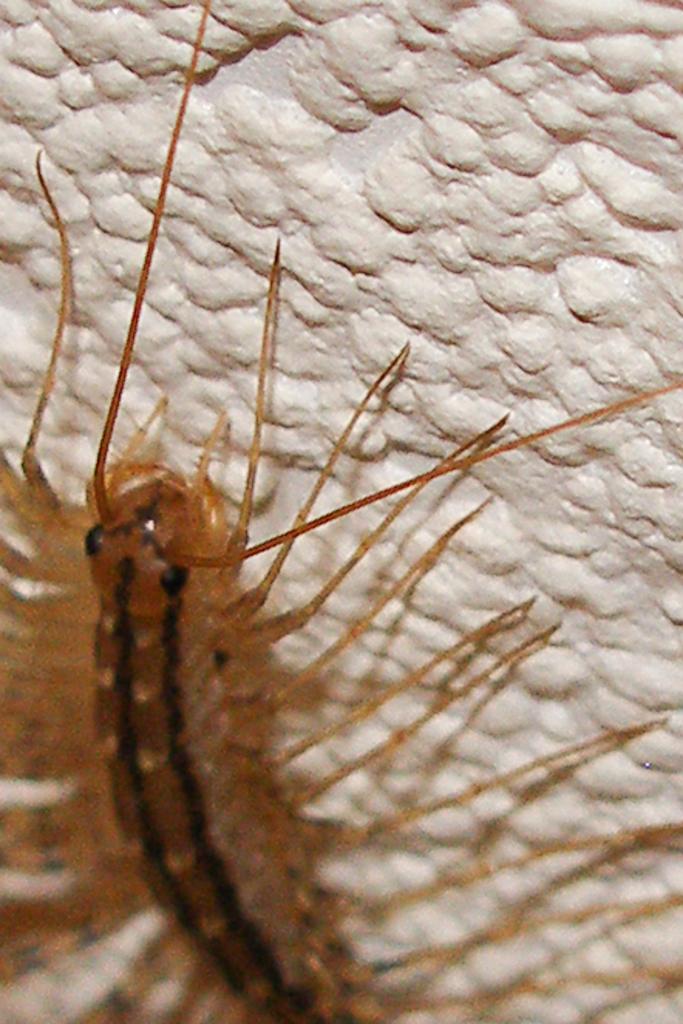Could you give a brief overview of what you see in this image? In this image we can see an insect present on the wall. 